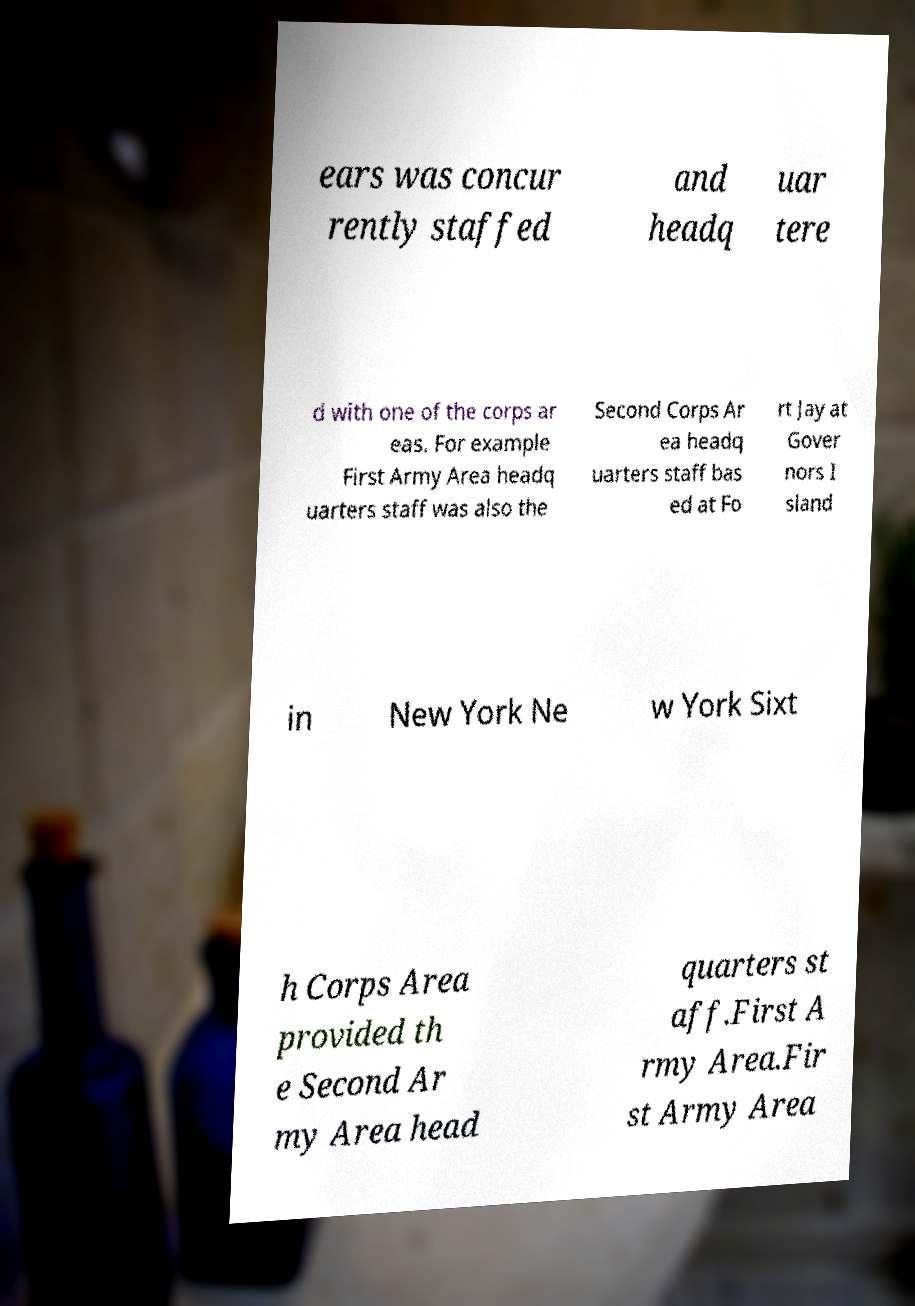I need the written content from this picture converted into text. Can you do that? ears was concur rently staffed and headq uar tere d with one of the corps ar eas. For example First Army Area headq uarters staff was also the Second Corps Ar ea headq uarters staff bas ed at Fo rt Jay at Gover nors I sland in New York Ne w York Sixt h Corps Area provided th e Second Ar my Area head quarters st aff.First A rmy Area.Fir st Army Area 